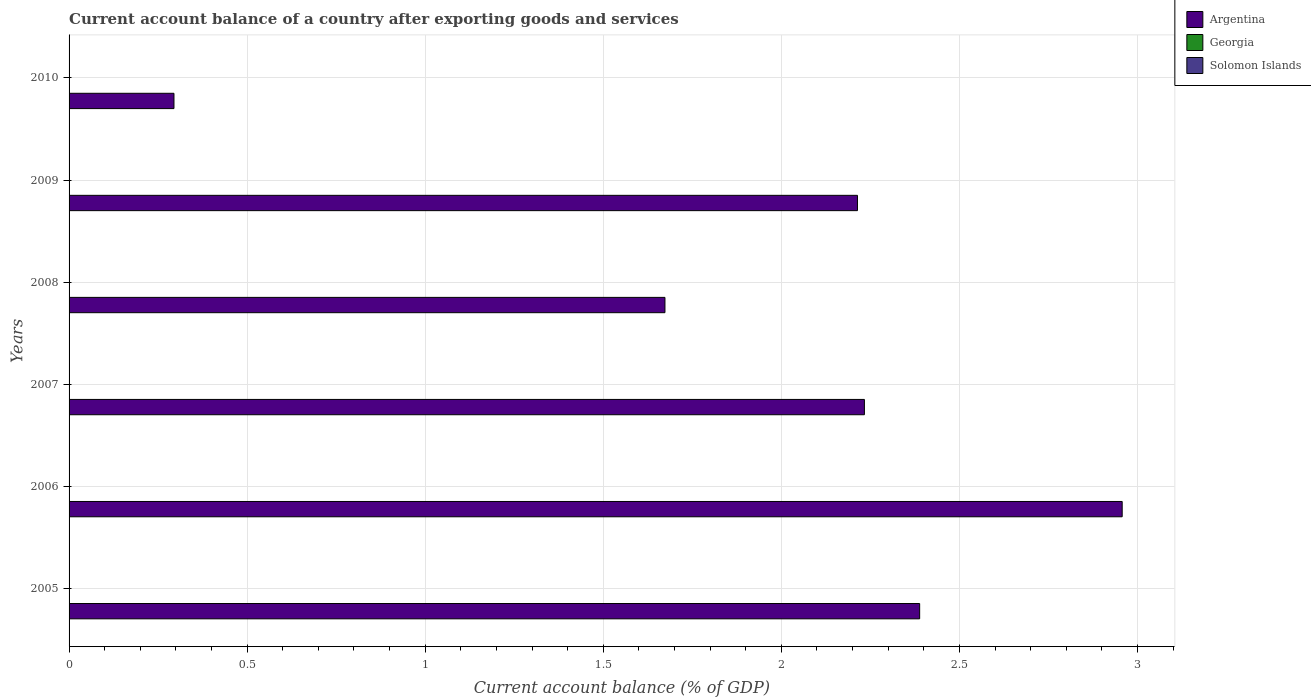Are the number of bars on each tick of the Y-axis equal?
Your response must be concise. Yes. How many bars are there on the 5th tick from the top?
Offer a terse response. 1. What is the label of the 2nd group of bars from the top?
Ensure brevity in your answer.  2009. What is the account balance in Georgia in 2007?
Make the answer very short. 0. Across all years, what is the maximum account balance in Argentina?
Provide a short and direct response. 2.96. Across all years, what is the minimum account balance in Argentina?
Offer a terse response. 0.29. What is the total account balance in Argentina in the graph?
Ensure brevity in your answer.  11.76. What is the difference between the account balance in Argentina in 2006 and that in 2007?
Your answer should be very brief. 0.72. What is the difference between the account balance in Argentina in 2010 and the account balance in Solomon Islands in 2005?
Provide a succinct answer. 0.29. In how many years, is the account balance in Argentina greater than 1.6 %?
Ensure brevity in your answer.  5. What is the ratio of the account balance in Argentina in 2008 to that in 2009?
Give a very brief answer. 0.76. Is the account balance in Argentina in 2006 less than that in 2010?
Your response must be concise. No. What is the difference between the highest and the second highest account balance in Argentina?
Provide a succinct answer. 0.57. What is the difference between the highest and the lowest account balance in Argentina?
Offer a terse response. 2.66. In how many years, is the account balance in Georgia greater than the average account balance in Georgia taken over all years?
Keep it short and to the point. 0. Is it the case that in every year, the sum of the account balance in Argentina and account balance in Georgia is greater than the account balance in Solomon Islands?
Keep it short and to the point. Yes. How many bars are there?
Ensure brevity in your answer.  6. Are all the bars in the graph horizontal?
Keep it short and to the point. Yes. How many legend labels are there?
Make the answer very short. 3. What is the title of the graph?
Give a very brief answer. Current account balance of a country after exporting goods and services. What is the label or title of the X-axis?
Offer a terse response. Current account balance (% of GDP). What is the Current account balance (% of GDP) of Argentina in 2005?
Make the answer very short. 2.39. What is the Current account balance (% of GDP) of Argentina in 2006?
Give a very brief answer. 2.96. What is the Current account balance (% of GDP) of Georgia in 2006?
Offer a very short reply. 0. What is the Current account balance (% of GDP) in Argentina in 2007?
Make the answer very short. 2.23. What is the Current account balance (% of GDP) in Georgia in 2007?
Your response must be concise. 0. What is the Current account balance (% of GDP) in Argentina in 2008?
Offer a very short reply. 1.67. What is the Current account balance (% of GDP) in Argentina in 2009?
Offer a very short reply. 2.21. What is the Current account balance (% of GDP) in Argentina in 2010?
Provide a short and direct response. 0.29. What is the Current account balance (% of GDP) of Georgia in 2010?
Ensure brevity in your answer.  0. Across all years, what is the maximum Current account balance (% of GDP) of Argentina?
Your response must be concise. 2.96. Across all years, what is the minimum Current account balance (% of GDP) in Argentina?
Make the answer very short. 0.29. What is the total Current account balance (% of GDP) in Argentina in the graph?
Make the answer very short. 11.76. What is the total Current account balance (% of GDP) of Georgia in the graph?
Ensure brevity in your answer.  0. What is the total Current account balance (% of GDP) of Solomon Islands in the graph?
Provide a succinct answer. 0. What is the difference between the Current account balance (% of GDP) of Argentina in 2005 and that in 2006?
Provide a succinct answer. -0.57. What is the difference between the Current account balance (% of GDP) in Argentina in 2005 and that in 2007?
Ensure brevity in your answer.  0.16. What is the difference between the Current account balance (% of GDP) in Argentina in 2005 and that in 2008?
Offer a terse response. 0.72. What is the difference between the Current account balance (% of GDP) in Argentina in 2005 and that in 2009?
Offer a very short reply. 0.17. What is the difference between the Current account balance (% of GDP) in Argentina in 2005 and that in 2010?
Offer a terse response. 2.09. What is the difference between the Current account balance (% of GDP) in Argentina in 2006 and that in 2007?
Your response must be concise. 0.72. What is the difference between the Current account balance (% of GDP) in Argentina in 2006 and that in 2008?
Provide a short and direct response. 1.28. What is the difference between the Current account balance (% of GDP) of Argentina in 2006 and that in 2009?
Provide a succinct answer. 0.74. What is the difference between the Current account balance (% of GDP) in Argentina in 2006 and that in 2010?
Keep it short and to the point. 2.66. What is the difference between the Current account balance (% of GDP) in Argentina in 2007 and that in 2008?
Ensure brevity in your answer.  0.56. What is the difference between the Current account balance (% of GDP) of Argentina in 2007 and that in 2009?
Provide a short and direct response. 0.02. What is the difference between the Current account balance (% of GDP) of Argentina in 2007 and that in 2010?
Your answer should be very brief. 1.94. What is the difference between the Current account balance (% of GDP) of Argentina in 2008 and that in 2009?
Give a very brief answer. -0.54. What is the difference between the Current account balance (% of GDP) in Argentina in 2008 and that in 2010?
Your response must be concise. 1.38. What is the difference between the Current account balance (% of GDP) in Argentina in 2009 and that in 2010?
Ensure brevity in your answer.  1.92. What is the average Current account balance (% of GDP) of Argentina per year?
Ensure brevity in your answer.  1.96. What is the ratio of the Current account balance (% of GDP) of Argentina in 2005 to that in 2006?
Your answer should be compact. 0.81. What is the ratio of the Current account balance (% of GDP) of Argentina in 2005 to that in 2007?
Provide a short and direct response. 1.07. What is the ratio of the Current account balance (% of GDP) in Argentina in 2005 to that in 2008?
Give a very brief answer. 1.43. What is the ratio of the Current account balance (% of GDP) in Argentina in 2005 to that in 2009?
Keep it short and to the point. 1.08. What is the ratio of the Current account balance (% of GDP) of Argentina in 2005 to that in 2010?
Offer a terse response. 8.11. What is the ratio of the Current account balance (% of GDP) of Argentina in 2006 to that in 2007?
Offer a terse response. 1.32. What is the ratio of the Current account balance (% of GDP) of Argentina in 2006 to that in 2008?
Keep it short and to the point. 1.77. What is the ratio of the Current account balance (% of GDP) of Argentina in 2006 to that in 2009?
Your response must be concise. 1.34. What is the ratio of the Current account balance (% of GDP) of Argentina in 2006 to that in 2010?
Your response must be concise. 10.04. What is the ratio of the Current account balance (% of GDP) in Argentina in 2007 to that in 2008?
Provide a succinct answer. 1.33. What is the ratio of the Current account balance (% of GDP) in Argentina in 2007 to that in 2009?
Provide a succinct answer. 1.01. What is the ratio of the Current account balance (% of GDP) of Argentina in 2007 to that in 2010?
Give a very brief answer. 7.58. What is the ratio of the Current account balance (% of GDP) in Argentina in 2008 to that in 2009?
Keep it short and to the point. 0.76. What is the ratio of the Current account balance (% of GDP) in Argentina in 2008 to that in 2010?
Your answer should be very brief. 5.68. What is the ratio of the Current account balance (% of GDP) of Argentina in 2009 to that in 2010?
Your answer should be compact. 7.52. What is the difference between the highest and the second highest Current account balance (% of GDP) in Argentina?
Make the answer very short. 0.57. What is the difference between the highest and the lowest Current account balance (% of GDP) of Argentina?
Make the answer very short. 2.66. 